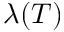Convert formula to latex. <formula><loc_0><loc_0><loc_500><loc_500>\lambda ( T )</formula> 